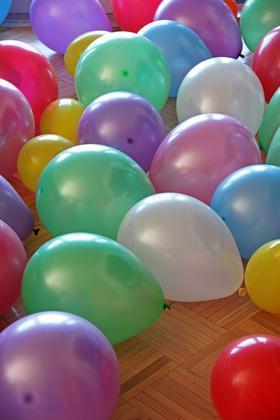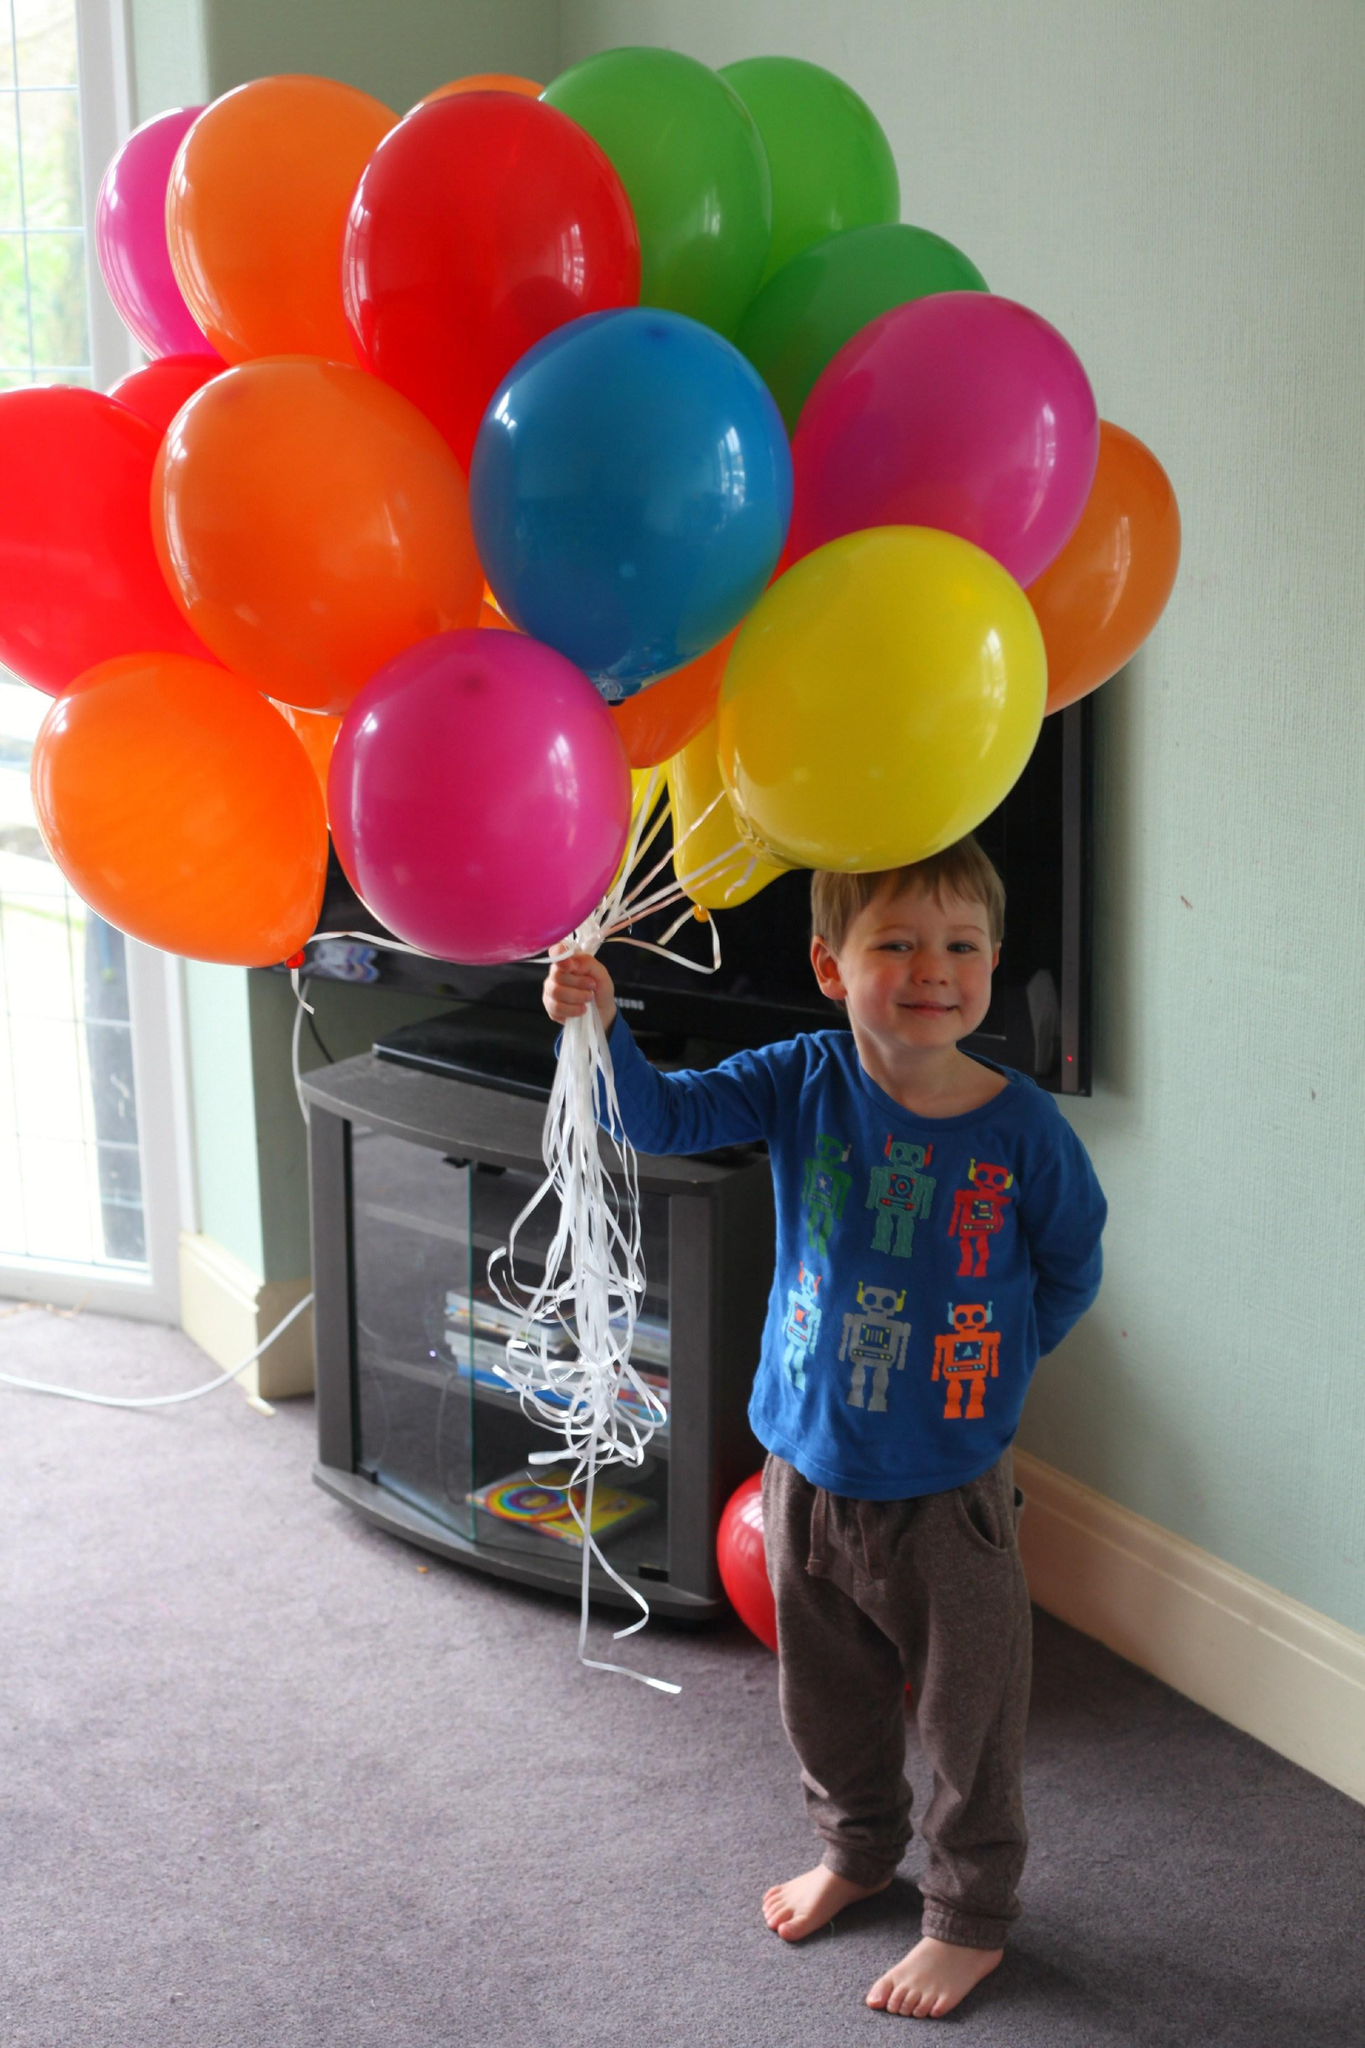The first image is the image on the left, the second image is the image on the right. Examine the images to the left and right. Is the description "In one image there is a person holding at least 1 balloon." accurate? Answer yes or no. Yes. The first image is the image on the left, the second image is the image on the right. Examine the images to the left and right. Is the description "One of the images shows someone holding at least one balloon and the other image shows a bunch of balloons in different colors." accurate? Answer yes or no. Yes. 